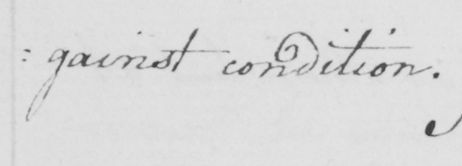Transcribe the text shown in this historical manuscript line. : gainst condition . 